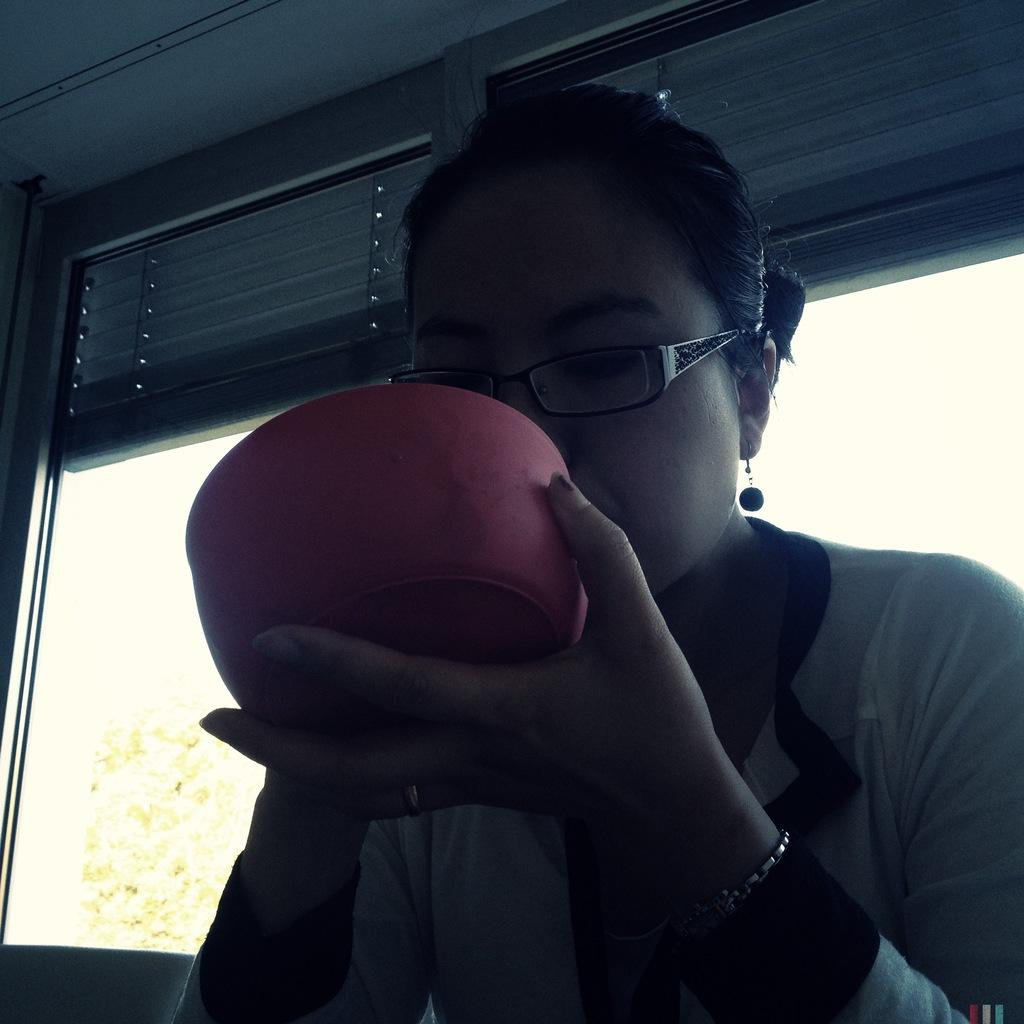What is the woman in the image doing? The woman is sitting in the image. What is the woman holding in the image? The woman is holding a bowl. What can be seen behind the woman in the image? There are windows behind the woman. What type of window treatment is present in the image? Window blinds are present. What is visible outside the window in the image? Trees are visible outside the window. What type of flowers can be seen in the bowl the woman is holding? There are no flowers visible in the image, as the woman is holding a bowl, but its contents are not specified. 